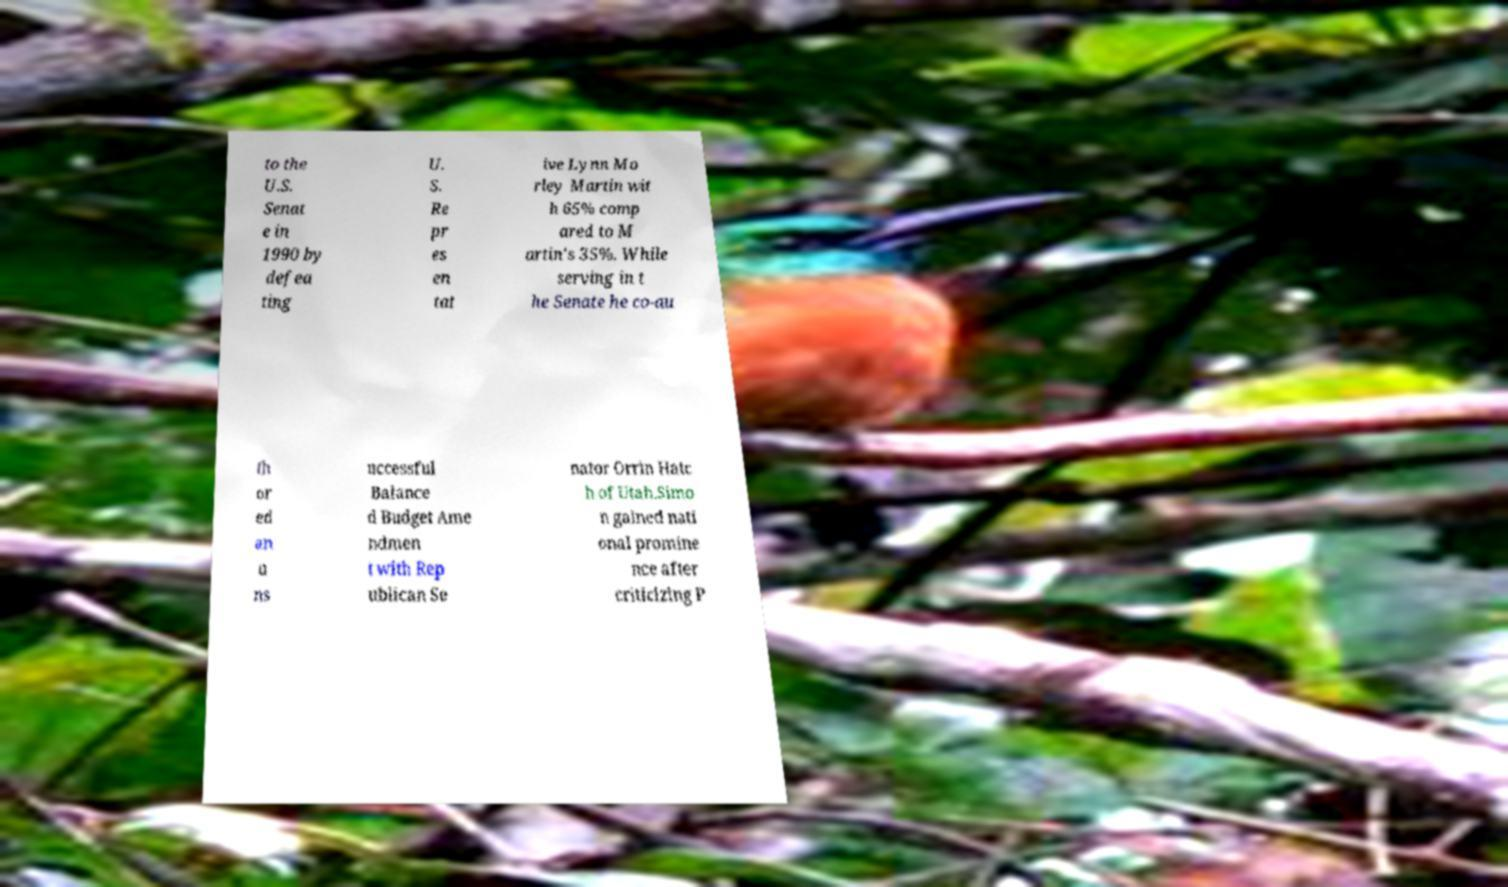Please identify and transcribe the text found in this image. to the U.S. Senat e in 1990 by defea ting U. S. Re pr es en tat ive Lynn Mo rley Martin wit h 65% comp ared to M artin's 35%. While serving in t he Senate he co-au th or ed an u ns uccessful Balance d Budget Ame ndmen t with Rep ublican Se nator Orrin Hatc h of Utah.Simo n gained nati onal promine nce after criticizing P 